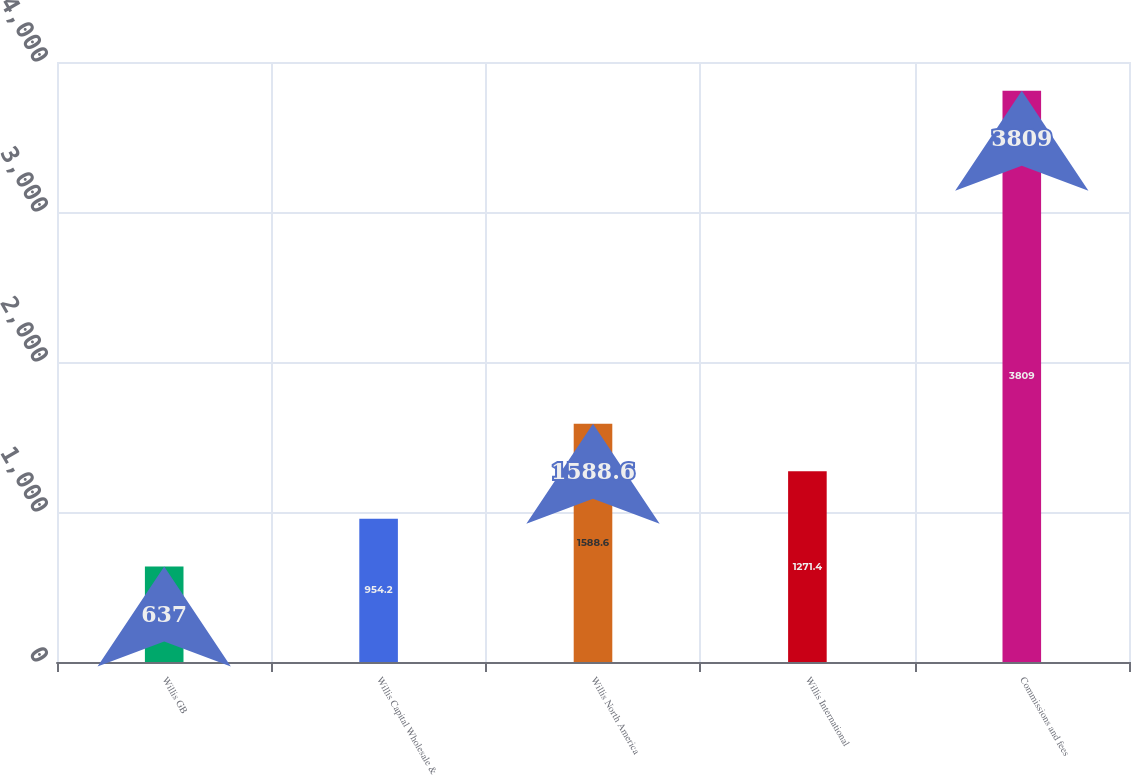Convert chart to OTSL. <chart><loc_0><loc_0><loc_500><loc_500><bar_chart><fcel>Willis GB<fcel>Willis Capital Wholesale &<fcel>Willis North America<fcel>Willis International<fcel>Commissions and fees<nl><fcel>637<fcel>954.2<fcel>1588.6<fcel>1271.4<fcel>3809<nl></chart> 